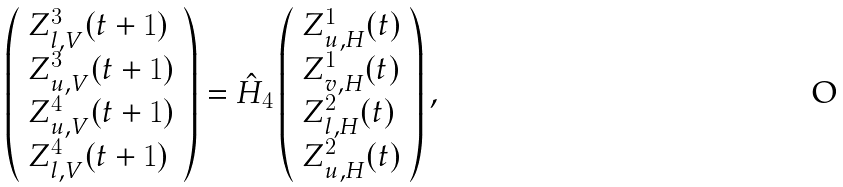Convert formula to latex. <formula><loc_0><loc_0><loc_500><loc_500>\left ( \begin{array} { l } Z _ { l , V } ^ { 3 } ( t + 1 ) \\ Z _ { u , V } ^ { 3 } ( t + 1 ) \\ Z _ { u , V } ^ { 4 } ( t + 1 ) \\ Z _ { l , V } ^ { 4 } ( t + 1 ) \end{array} \right ) = \hat { H } _ { 4 } \left ( \begin{array} { l } Z _ { u , H } ^ { 1 } ( t ) \\ Z _ { v , H } ^ { 1 } ( t ) \\ Z _ { l , H } ^ { 2 } ( t ) \\ Z _ { u , H } ^ { 2 } ( t ) \end{array} \right ) ,</formula> 